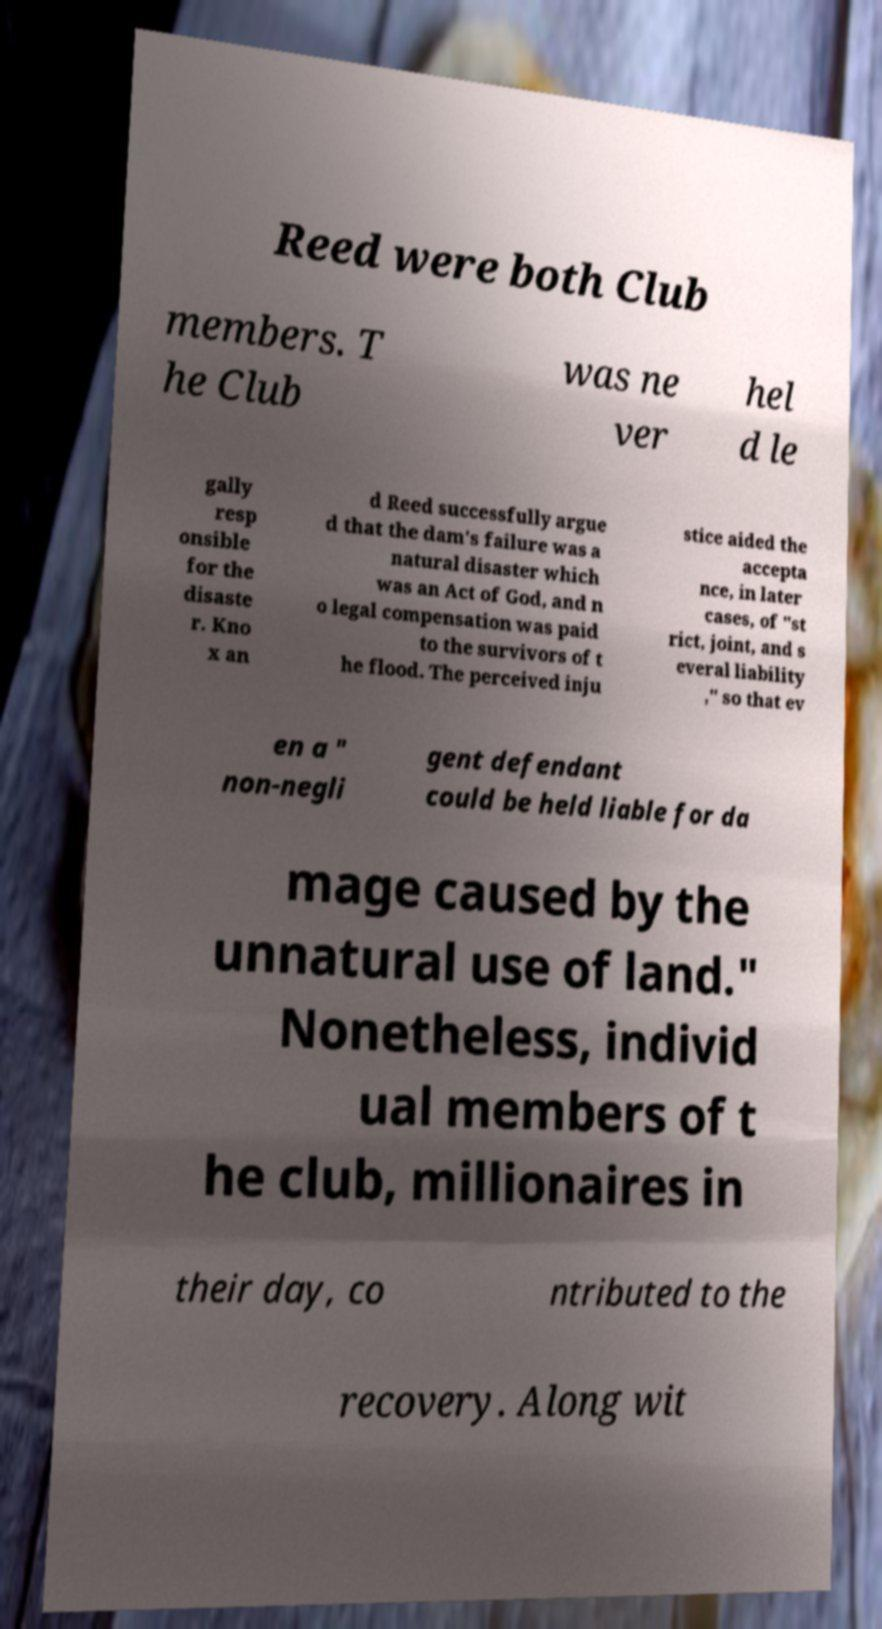Please read and relay the text visible in this image. What does it say? Reed were both Club members. T he Club was ne ver hel d le gally resp onsible for the disaste r. Kno x an d Reed successfully argue d that the dam's failure was a natural disaster which was an Act of God, and n o legal compensation was paid to the survivors of t he flood. The perceived inju stice aided the accepta nce, in later cases, of "st rict, joint, and s everal liability ," so that ev en a " non-negli gent defendant could be held liable for da mage caused by the unnatural use of land." Nonetheless, individ ual members of t he club, millionaires in their day, co ntributed to the recovery. Along wit 